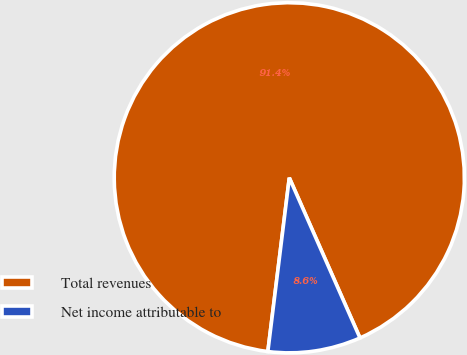Convert chart to OTSL. <chart><loc_0><loc_0><loc_500><loc_500><pie_chart><fcel>Total revenues<fcel>Net income attributable to<nl><fcel>91.43%<fcel>8.57%<nl></chart> 